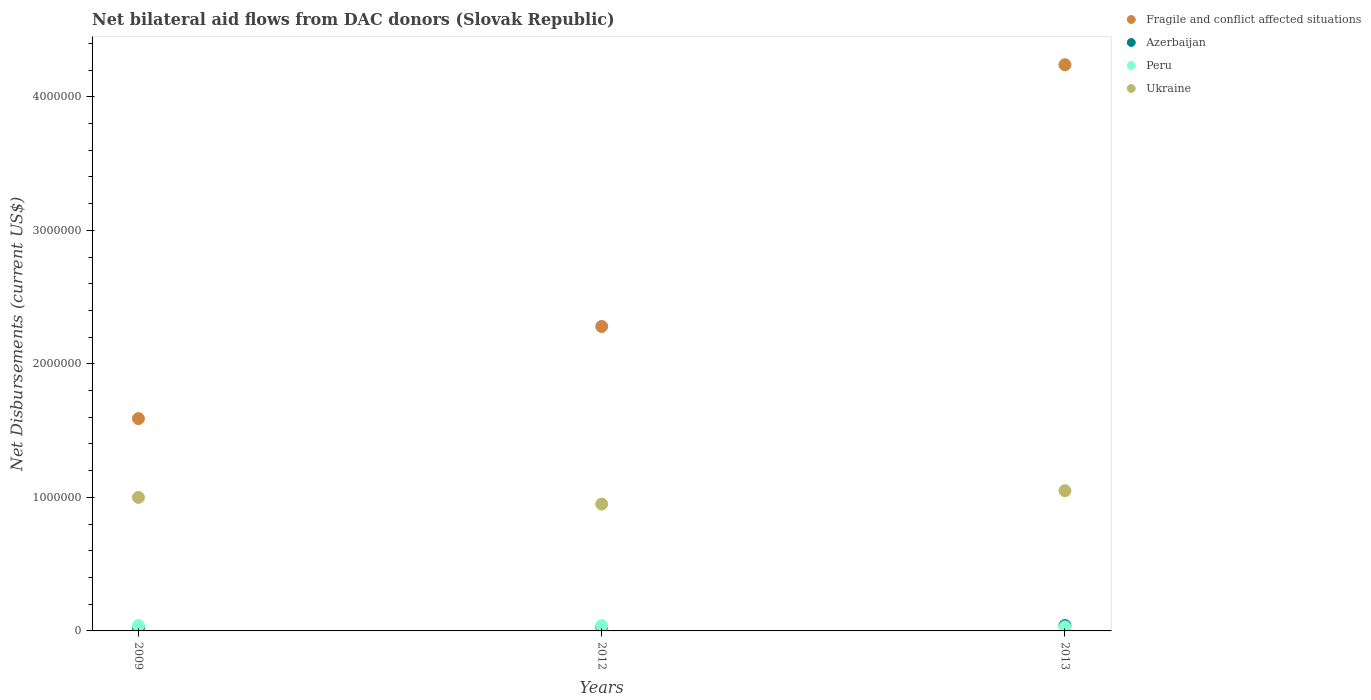What is the net bilateral aid flows in Ukraine in 2012?
Your answer should be compact. 9.50e+05. Across all years, what is the maximum net bilateral aid flows in Azerbaijan?
Provide a short and direct response. 4.00e+04. Across all years, what is the minimum net bilateral aid flows in Ukraine?
Offer a terse response. 9.50e+05. In which year was the net bilateral aid flows in Peru maximum?
Offer a terse response. 2009. In which year was the net bilateral aid flows in Fragile and conflict affected situations minimum?
Keep it short and to the point. 2009. What is the total net bilateral aid flows in Fragile and conflict affected situations in the graph?
Offer a very short reply. 8.11e+06. What is the difference between the net bilateral aid flows in Peru in 2009 and the net bilateral aid flows in Ukraine in 2012?
Make the answer very short. -9.10e+05. What is the average net bilateral aid flows in Azerbaijan per year?
Provide a succinct answer. 3.00e+04. In the year 2013, what is the difference between the net bilateral aid flows in Azerbaijan and net bilateral aid flows in Ukraine?
Make the answer very short. -1.01e+06. In how many years, is the net bilateral aid flows in Azerbaijan greater than 800000 US$?
Give a very brief answer. 0. What is the ratio of the net bilateral aid flows in Fragile and conflict affected situations in 2009 to that in 2012?
Provide a succinct answer. 0.7. Is the difference between the net bilateral aid flows in Azerbaijan in 2012 and 2013 greater than the difference between the net bilateral aid flows in Ukraine in 2012 and 2013?
Your response must be concise. Yes. What is the difference between the highest and the lowest net bilateral aid flows in Ukraine?
Your answer should be very brief. 1.00e+05. In how many years, is the net bilateral aid flows in Ukraine greater than the average net bilateral aid flows in Ukraine taken over all years?
Keep it short and to the point. 1. Is the sum of the net bilateral aid flows in Fragile and conflict affected situations in 2009 and 2012 greater than the maximum net bilateral aid flows in Azerbaijan across all years?
Your response must be concise. Yes. Are the values on the major ticks of Y-axis written in scientific E-notation?
Provide a short and direct response. No. Does the graph contain any zero values?
Provide a succinct answer. No. What is the title of the graph?
Provide a short and direct response. Net bilateral aid flows from DAC donors (Slovak Republic). Does "Gambia, The" appear as one of the legend labels in the graph?
Keep it short and to the point. No. What is the label or title of the Y-axis?
Your answer should be very brief. Net Disbursements (current US$). What is the Net Disbursements (current US$) of Fragile and conflict affected situations in 2009?
Offer a very short reply. 1.59e+06. What is the Net Disbursements (current US$) of Azerbaijan in 2009?
Your answer should be compact. 2.00e+04. What is the Net Disbursements (current US$) in Ukraine in 2009?
Offer a very short reply. 1.00e+06. What is the Net Disbursements (current US$) of Fragile and conflict affected situations in 2012?
Offer a very short reply. 2.28e+06. What is the Net Disbursements (current US$) of Peru in 2012?
Offer a very short reply. 4.00e+04. What is the Net Disbursements (current US$) in Ukraine in 2012?
Provide a succinct answer. 9.50e+05. What is the Net Disbursements (current US$) in Fragile and conflict affected situations in 2013?
Your answer should be compact. 4.24e+06. What is the Net Disbursements (current US$) of Peru in 2013?
Offer a terse response. 3.00e+04. What is the Net Disbursements (current US$) of Ukraine in 2013?
Ensure brevity in your answer.  1.05e+06. Across all years, what is the maximum Net Disbursements (current US$) in Fragile and conflict affected situations?
Make the answer very short. 4.24e+06. Across all years, what is the maximum Net Disbursements (current US$) of Azerbaijan?
Keep it short and to the point. 4.00e+04. Across all years, what is the maximum Net Disbursements (current US$) of Ukraine?
Ensure brevity in your answer.  1.05e+06. Across all years, what is the minimum Net Disbursements (current US$) of Fragile and conflict affected situations?
Your answer should be compact. 1.59e+06. Across all years, what is the minimum Net Disbursements (current US$) of Peru?
Your answer should be very brief. 3.00e+04. Across all years, what is the minimum Net Disbursements (current US$) of Ukraine?
Keep it short and to the point. 9.50e+05. What is the total Net Disbursements (current US$) in Fragile and conflict affected situations in the graph?
Your response must be concise. 8.11e+06. What is the total Net Disbursements (current US$) in Azerbaijan in the graph?
Ensure brevity in your answer.  9.00e+04. What is the total Net Disbursements (current US$) of Peru in the graph?
Offer a terse response. 1.10e+05. What is the total Net Disbursements (current US$) in Ukraine in the graph?
Offer a very short reply. 3.00e+06. What is the difference between the Net Disbursements (current US$) of Fragile and conflict affected situations in 2009 and that in 2012?
Make the answer very short. -6.90e+05. What is the difference between the Net Disbursements (current US$) in Azerbaijan in 2009 and that in 2012?
Offer a very short reply. -10000. What is the difference between the Net Disbursements (current US$) of Peru in 2009 and that in 2012?
Make the answer very short. 0. What is the difference between the Net Disbursements (current US$) of Ukraine in 2009 and that in 2012?
Provide a short and direct response. 5.00e+04. What is the difference between the Net Disbursements (current US$) of Fragile and conflict affected situations in 2009 and that in 2013?
Your answer should be compact. -2.65e+06. What is the difference between the Net Disbursements (current US$) of Azerbaijan in 2009 and that in 2013?
Offer a very short reply. -2.00e+04. What is the difference between the Net Disbursements (current US$) in Fragile and conflict affected situations in 2012 and that in 2013?
Make the answer very short. -1.96e+06. What is the difference between the Net Disbursements (current US$) in Azerbaijan in 2012 and that in 2013?
Your answer should be compact. -10000. What is the difference between the Net Disbursements (current US$) of Peru in 2012 and that in 2013?
Give a very brief answer. 10000. What is the difference between the Net Disbursements (current US$) in Ukraine in 2012 and that in 2013?
Your answer should be compact. -1.00e+05. What is the difference between the Net Disbursements (current US$) in Fragile and conflict affected situations in 2009 and the Net Disbursements (current US$) in Azerbaijan in 2012?
Keep it short and to the point. 1.56e+06. What is the difference between the Net Disbursements (current US$) in Fragile and conflict affected situations in 2009 and the Net Disbursements (current US$) in Peru in 2012?
Your answer should be very brief. 1.55e+06. What is the difference between the Net Disbursements (current US$) in Fragile and conflict affected situations in 2009 and the Net Disbursements (current US$) in Ukraine in 2012?
Offer a very short reply. 6.40e+05. What is the difference between the Net Disbursements (current US$) in Azerbaijan in 2009 and the Net Disbursements (current US$) in Peru in 2012?
Provide a short and direct response. -2.00e+04. What is the difference between the Net Disbursements (current US$) of Azerbaijan in 2009 and the Net Disbursements (current US$) of Ukraine in 2012?
Offer a terse response. -9.30e+05. What is the difference between the Net Disbursements (current US$) of Peru in 2009 and the Net Disbursements (current US$) of Ukraine in 2012?
Your response must be concise. -9.10e+05. What is the difference between the Net Disbursements (current US$) of Fragile and conflict affected situations in 2009 and the Net Disbursements (current US$) of Azerbaijan in 2013?
Provide a short and direct response. 1.55e+06. What is the difference between the Net Disbursements (current US$) in Fragile and conflict affected situations in 2009 and the Net Disbursements (current US$) in Peru in 2013?
Offer a terse response. 1.56e+06. What is the difference between the Net Disbursements (current US$) in Fragile and conflict affected situations in 2009 and the Net Disbursements (current US$) in Ukraine in 2013?
Keep it short and to the point. 5.40e+05. What is the difference between the Net Disbursements (current US$) in Azerbaijan in 2009 and the Net Disbursements (current US$) in Peru in 2013?
Keep it short and to the point. -10000. What is the difference between the Net Disbursements (current US$) in Azerbaijan in 2009 and the Net Disbursements (current US$) in Ukraine in 2013?
Ensure brevity in your answer.  -1.03e+06. What is the difference between the Net Disbursements (current US$) of Peru in 2009 and the Net Disbursements (current US$) of Ukraine in 2013?
Your answer should be very brief. -1.01e+06. What is the difference between the Net Disbursements (current US$) of Fragile and conflict affected situations in 2012 and the Net Disbursements (current US$) of Azerbaijan in 2013?
Your response must be concise. 2.24e+06. What is the difference between the Net Disbursements (current US$) of Fragile and conflict affected situations in 2012 and the Net Disbursements (current US$) of Peru in 2013?
Make the answer very short. 2.25e+06. What is the difference between the Net Disbursements (current US$) in Fragile and conflict affected situations in 2012 and the Net Disbursements (current US$) in Ukraine in 2013?
Give a very brief answer. 1.23e+06. What is the difference between the Net Disbursements (current US$) of Azerbaijan in 2012 and the Net Disbursements (current US$) of Ukraine in 2013?
Keep it short and to the point. -1.02e+06. What is the difference between the Net Disbursements (current US$) of Peru in 2012 and the Net Disbursements (current US$) of Ukraine in 2013?
Your answer should be very brief. -1.01e+06. What is the average Net Disbursements (current US$) in Fragile and conflict affected situations per year?
Make the answer very short. 2.70e+06. What is the average Net Disbursements (current US$) in Peru per year?
Give a very brief answer. 3.67e+04. What is the average Net Disbursements (current US$) in Ukraine per year?
Your answer should be very brief. 1.00e+06. In the year 2009, what is the difference between the Net Disbursements (current US$) of Fragile and conflict affected situations and Net Disbursements (current US$) of Azerbaijan?
Offer a terse response. 1.57e+06. In the year 2009, what is the difference between the Net Disbursements (current US$) of Fragile and conflict affected situations and Net Disbursements (current US$) of Peru?
Provide a succinct answer. 1.55e+06. In the year 2009, what is the difference between the Net Disbursements (current US$) of Fragile and conflict affected situations and Net Disbursements (current US$) of Ukraine?
Your answer should be very brief. 5.90e+05. In the year 2009, what is the difference between the Net Disbursements (current US$) of Azerbaijan and Net Disbursements (current US$) of Ukraine?
Provide a succinct answer. -9.80e+05. In the year 2009, what is the difference between the Net Disbursements (current US$) in Peru and Net Disbursements (current US$) in Ukraine?
Your answer should be compact. -9.60e+05. In the year 2012, what is the difference between the Net Disbursements (current US$) of Fragile and conflict affected situations and Net Disbursements (current US$) of Azerbaijan?
Give a very brief answer. 2.25e+06. In the year 2012, what is the difference between the Net Disbursements (current US$) in Fragile and conflict affected situations and Net Disbursements (current US$) in Peru?
Make the answer very short. 2.24e+06. In the year 2012, what is the difference between the Net Disbursements (current US$) of Fragile and conflict affected situations and Net Disbursements (current US$) of Ukraine?
Ensure brevity in your answer.  1.33e+06. In the year 2012, what is the difference between the Net Disbursements (current US$) in Azerbaijan and Net Disbursements (current US$) in Peru?
Offer a terse response. -10000. In the year 2012, what is the difference between the Net Disbursements (current US$) of Azerbaijan and Net Disbursements (current US$) of Ukraine?
Offer a very short reply. -9.20e+05. In the year 2012, what is the difference between the Net Disbursements (current US$) in Peru and Net Disbursements (current US$) in Ukraine?
Your response must be concise. -9.10e+05. In the year 2013, what is the difference between the Net Disbursements (current US$) of Fragile and conflict affected situations and Net Disbursements (current US$) of Azerbaijan?
Offer a very short reply. 4.20e+06. In the year 2013, what is the difference between the Net Disbursements (current US$) in Fragile and conflict affected situations and Net Disbursements (current US$) in Peru?
Keep it short and to the point. 4.21e+06. In the year 2013, what is the difference between the Net Disbursements (current US$) of Fragile and conflict affected situations and Net Disbursements (current US$) of Ukraine?
Offer a very short reply. 3.19e+06. In the year 2013, what is the difference between the Net Disbursements (current US$) of Azerbaijan and Net Disbursements (current US$) of Peru?
Provide a succinct answer. 10000. In the year 2013, what is the difference between the Net Disbursements (current US$) in Azerbaijan and Net Disbursements (current US$) in Ukraine?
Provide a succinct answer. -1.01e+06. In the year 2013, what is the difference between the Net Disbursements (current US$) of Peru and Net Disbursements (current US$) of Ukraine?
Offer a terse response. -1.02e+06. What is the ratio of the Net Disbursements (current US$) in Fragile and conflict affected situations in 2009 to that in 2012?
Offer a terse response. 0.7. What is the ratio of the Net Disbursements (current US$) in Azerbaijan in 2009 to that in 2012?
Ensure brevity in your answer.  0.67. What is the ratio of the Net Disbursements (current US$) in Ukraine in 2009 to that in 2012?
Provide a short and direct response. 1.05. What is the ratio of the Net Disbursements (current US$) of Fragile and conflict affected situations in 2009 to that in 2013?
Provide a succinct answer. 0.38. What is the ratio of the Net Disbursements (current US$) in Peru in 2009 to that in 2013?
Ensure brevity in your answer.  1.33. What is the ratio of the Net Disbursements (current US$) of Fragile and conflict affected situations in 2012 to that in 2013?
Offer a very short reply. 0.54. What is the ratio of the Net Disbursements (current US$) in Peru in 2012 to that in 2013?
Your answer should be very brief. 1.33. What is the ratio of the Net Disbursements (current US$) of Ukraine in 2012 to that in 2013?
Offer a terse response. 0.9. What is the difference between the highest and the second highest Net Disbursements (current US$) of Fragile and conflict affected situations?
Your answer should be very brief. 1.96e+06. What is the difference between the highest and the lowest Net Disbursements (current US$) of Fragile and conflict affected situations?
Your answer should be compact. 2.65e+06. What is the difference between the highest and the lowest Net Disbursements (current US$) in Azerbaijan?
Provide a short and direct response. 2.00e+04. What is the difference between the highest and the lowest Net Disbursements (current US$) in Peru?
Offer a terse response. 10000. What is the difference between the highest and the lowest Net Disbursements (current US$) in Ukraine?
Make the answer very short. 1.00e+05. 